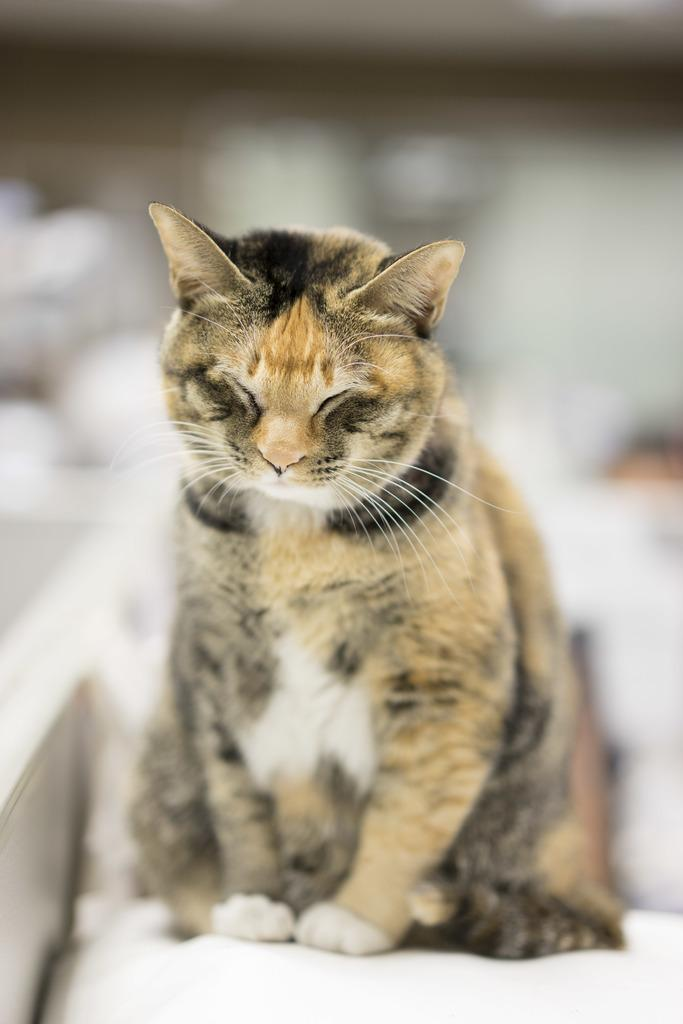What type of animal is in the image? There is a cat in the image. What is the cat doing in the image? The cat is sitting on a surface. How is the background of the image depicted? The background of the cat is blurred. What type of statement is the cat making in the image? There is no statement being made by the cat in the image, as cats cannot speak or make statements. 